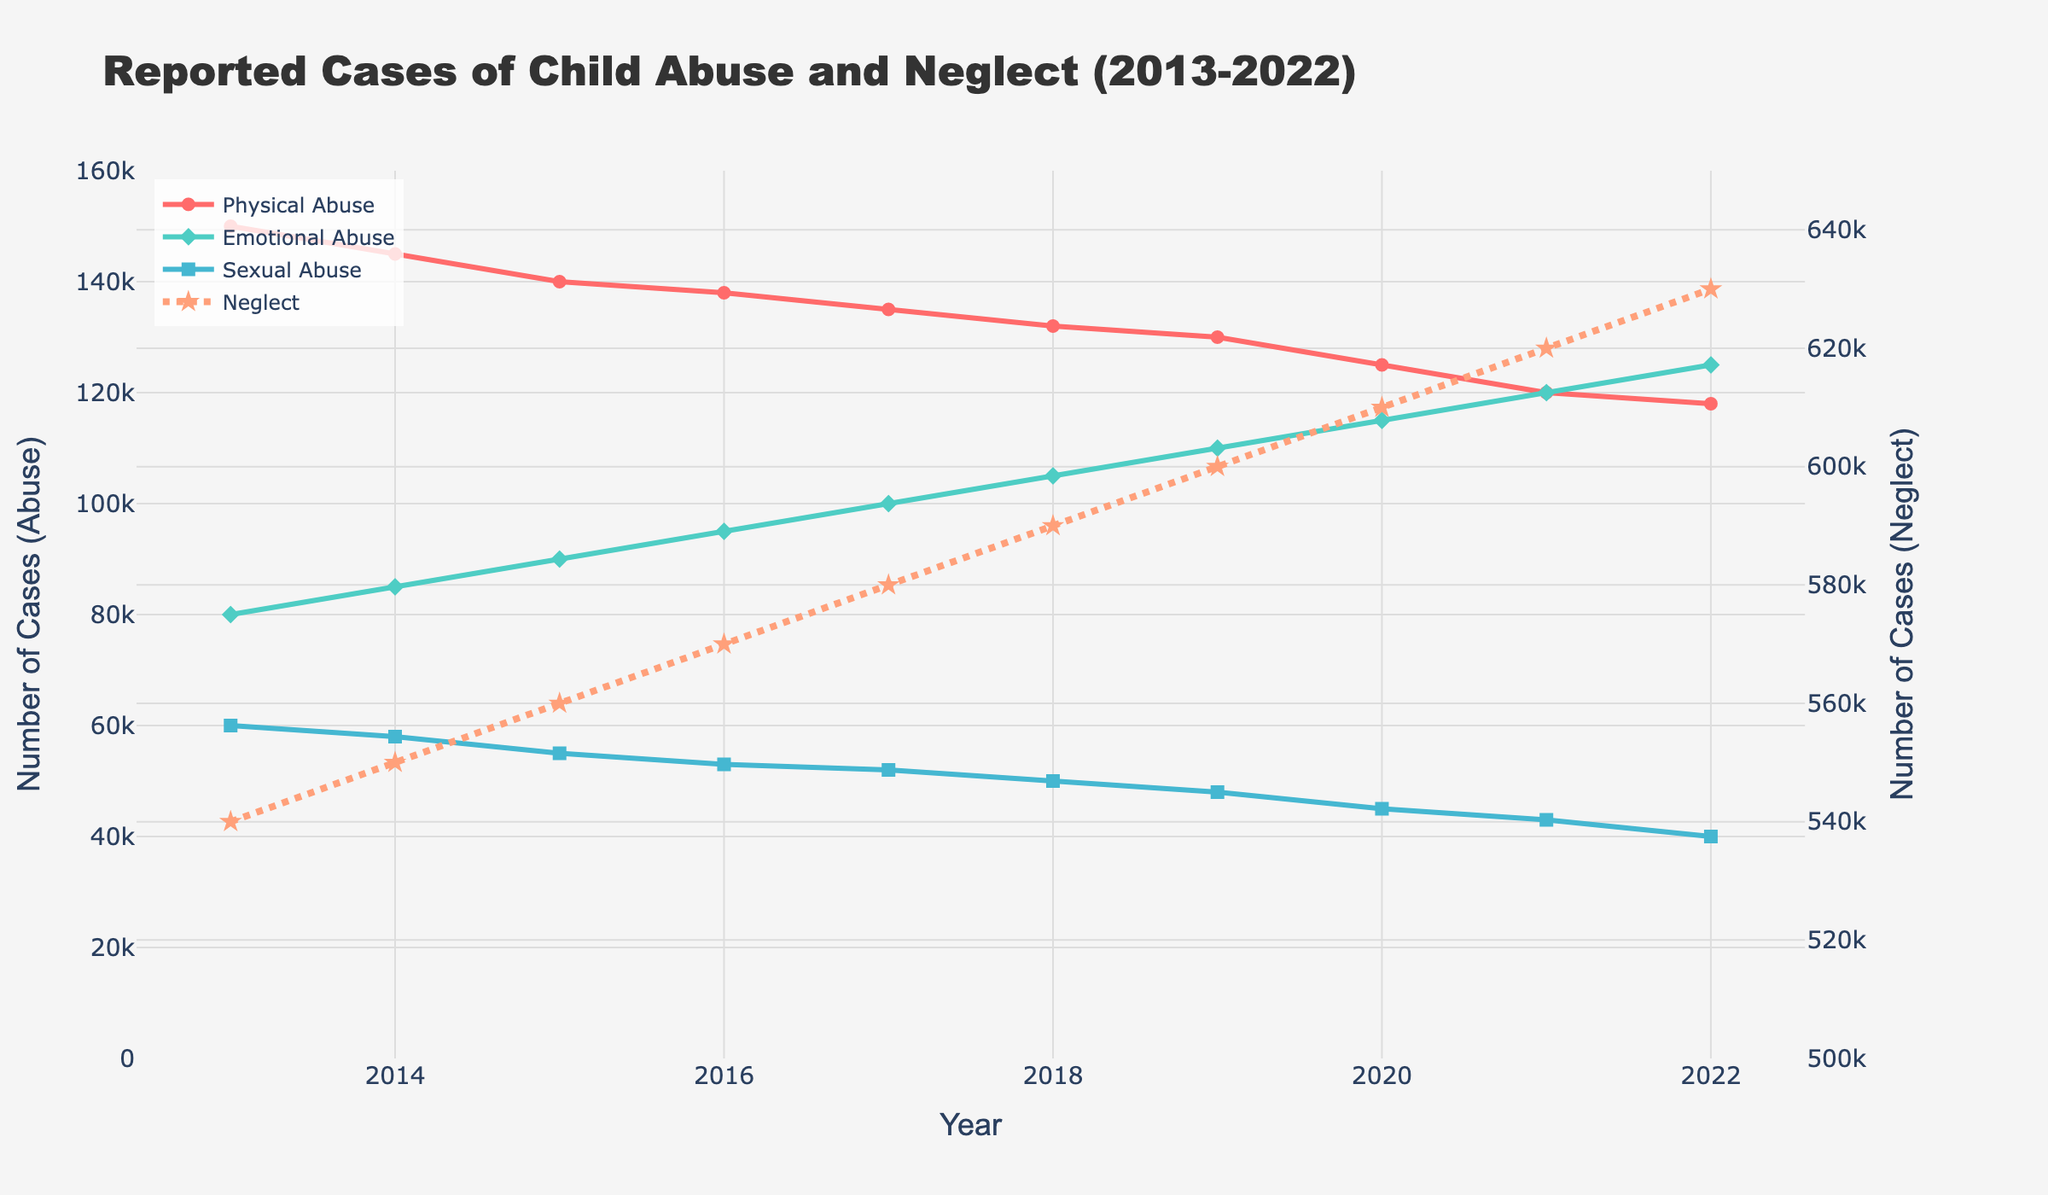What's the trend in the number of reported cases of neglect from 2013 to 2022? To find the trend, look at the line representing neglect (star markers and dotted line) from 2013 to 2022. Observe if it is generally increasing, decreasing, or stable. In this case, the line is increasing steadily.
Answer: Increasing Between 2013 and 2022, in which year did Emotional Abuse cases surpass Physical Abuse cases? Compare the two lines (green for Emotional Abuse and red for Physical Abuse) representing each type of abuse over the years. Identify the first year where the green line is above the red line. Emotional Abuse cases surpass Physical Abuse cases for the first time in 2014.
Answer: 2014 Which type of abuse had the most significant drop in reported cases over the decade? Compare the initial and final values of the lines representing each type of abuse. Calculate the difference for each type. Physical Abuse dropped from 150,000 to 118,000 (a drop of 32,000), Emotional Abuse increased, Sexual Abuse dropped from 60,000 to 40,000 (a drop of 20,000), and Neglect increased. Therefore, Physical Abuse had the most significant drop.
Answer: Physical Abuse How many total cases of abuse (sum of Physical, Emotional, and Sexual) were reported in 2015? Sum the number of cases reported for each type of abuse in 2015: Physical Abuse (140,000), Emotional Abuse (90,000), and Sexual Abuse (55,000). So, 140,000 + 90,000 + 55,000 = 285,000.
Answer: 285,000 In which year was the difference between Emotional Abuse and Sexual Abuse cases the greatest, and what was the difference? Calculate the difference between Emotional Abuse and Sexual Abuse for each year. Find the year with the maximum difference. In 2022, Emotional Abuse (125,000) - Sexual Abuse (40,000) results in the highest difference: 125,000 - 40,000 = 85,000.
Answer: 2022, 85,000 Compare the relative increase in Emotional Abuse and Neglect cases from 2013 to 2022. Which one had the higher percentage increase? Calculate the percentage increase for each type. For Emotional Abuse: ((125,000 - 80,000) / 80,000) * 100 = 56.25%. For Neglect: ((630,000 - 540,000) / 540,000) * 100 = 16.67%. Emotional Abuse had a higher percentage increase.
Answer: Emotional Abuse Which type of abuse consistently had the lowest number of reported cases each year? Identify the line that is always positioned the lowest on the y-axis across all years. Sexual Abuse consistently had the lowest number of reported cases each year.
Answer: Sexual Abuse What is the average number of reported Physical Abuse cases from 2013 to 2022? Sum the reported cases of Physical Abuse from 2013 to 2022 and divide by the number of years (10). (150,000 + 145,000 + 140,000 + 138,000 + 135,000 + 132,000 + 130,000 + 125,000 + 120,000 + 118,000) / 10 = 133,300.
Answer: 133,300 What was the overall trend for Sexual Abuse cases? Look at the line representing Sexual Abuse cases (blue line with square markers) from 2013 to 2022. Observe if it is generally increasing, decreasing, or stable. In this case, the trend shows a steady decrease.
Answer: Decreasing 